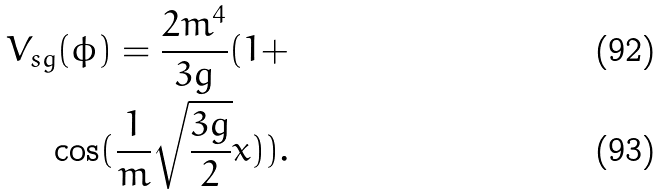Convert formula to latex. <formula><loc_0><loc_0><loc_500><loc_500>V _ { s g } ( \phi ) = \frac { 2 m ^ { 4 } } { 3 g } ( 1 + \\ \cos ( \frac { 1 } { m } \sqrt { \frac { 3 g } { 2 } } x ) ) .</formula> 